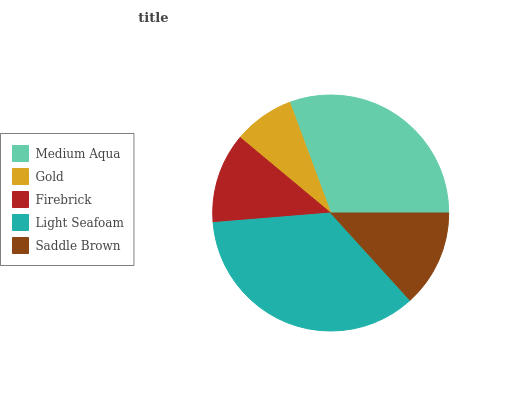Is Gold the minimum?
Answer yes or no. Yes. Is Light Seafoam the maximum?
Answer yes or no. Yes. Is Firebrick the minimum?
Answer yes or no. No. Is Firebrick the maximum?
Answer yes or no. No. Is Firebrick greater than Gold?
Answer yes or no. Yes. Is Gold less than Firebrick?
Answer yes or no. Yes. Is Gold greater than Firebrick?
Answer yes or no. No. Is Firebrick less than Gold?
Answer yes or no. No. Is Saddle Brown the high median?
Answer yes or no. Yes. Is Saddle Brown the low median?
Answer yes or no. Yes. Is Firebrick the high median?
Answer yes or no. No. Is Firebrick the low median?
Answer yes or no. No. 